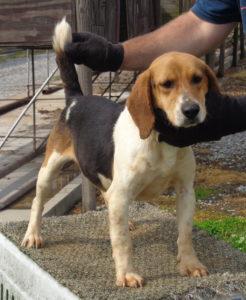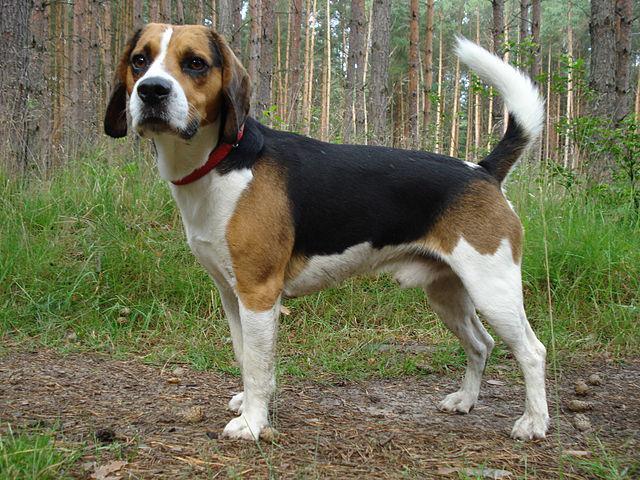The first image is the image on the left, the second image is the image on the right. For the images shown, is this caption "There is at least two dogs in the left image." true? Answer yes or no. No. The first image is the image on the left, the second image is the image on the right. Analyze the images presented: Is the assertion "Each image contains one beagle standing on all fours with its tail up, and the beagle on the right wears a red collar." valid? Answer yes or no. Yes. 